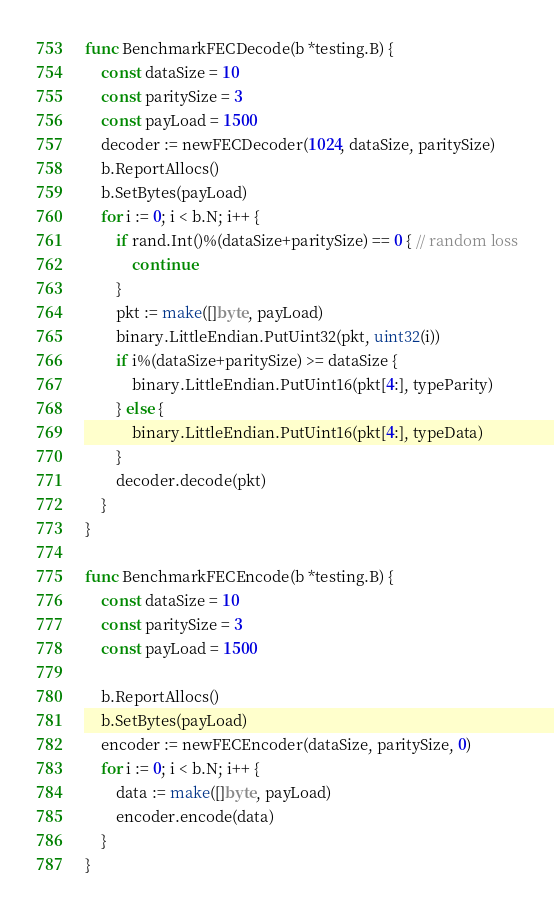<code> <loc_0><loc_0><loc_500><loc_500><_Go_>func BenchmarkFECDecode(b *testing.B) {
	const dataSize = 10
	const paritySize = 3
	const payLoad = 1500
	decoder := newFECDecoder(1024, dataSize, paritySize)
	b.ReportAllocs()
	b.SetBytes(payLoad)
	for i := 0; i < b.N; i++ {
		if rand.Int()%(dataSize+paritySize) == 0 { // random loss
			continue
		}
		pkt := make([]byte, payLoad)
		binary.LittleEndian.PutUint32(pkt, uint32(i))
		if i%(dataSize+paritySize) >= dataSize {
			binary.LittleEndian.PutUint16(pkt[4:], typeParity)
		} else {
			binary.LittleEndian.PutUint16(pkt[4:], typeData)
		}
		decoder.decode(pkt)
	}
}

func BenchmarkFECEncode(b *testing.B) {
	const dataSize = 10
	const paritySize = 3
	const payLoad = 1500

	b.ReportAllocs()
	b.SetBytes(payLoad)
	encoder := newFECEncoder(dataSize, paritySize, 0)
	for i := 0; i < b.N; i++ {
		data := make([]byte, payLoad)
		encoder.encode(data)
	}
}
</code> 